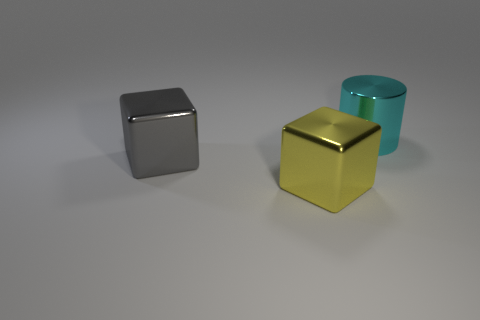Add 3 red cubes. How many objects exist? 6 Subtract all cylinders. How many objects are left? 2 Subtract 1 yellow blocks. How many objects are left? 2 Subtract all yellow metal cubes. Subtract all blocks. How many objects are left? 0 Add 2 gray metallic blocks. How many gray metallic blocks are left? 3 Add 1 big purple matte cylinders. How many big purple matte cylinders exist? 1 